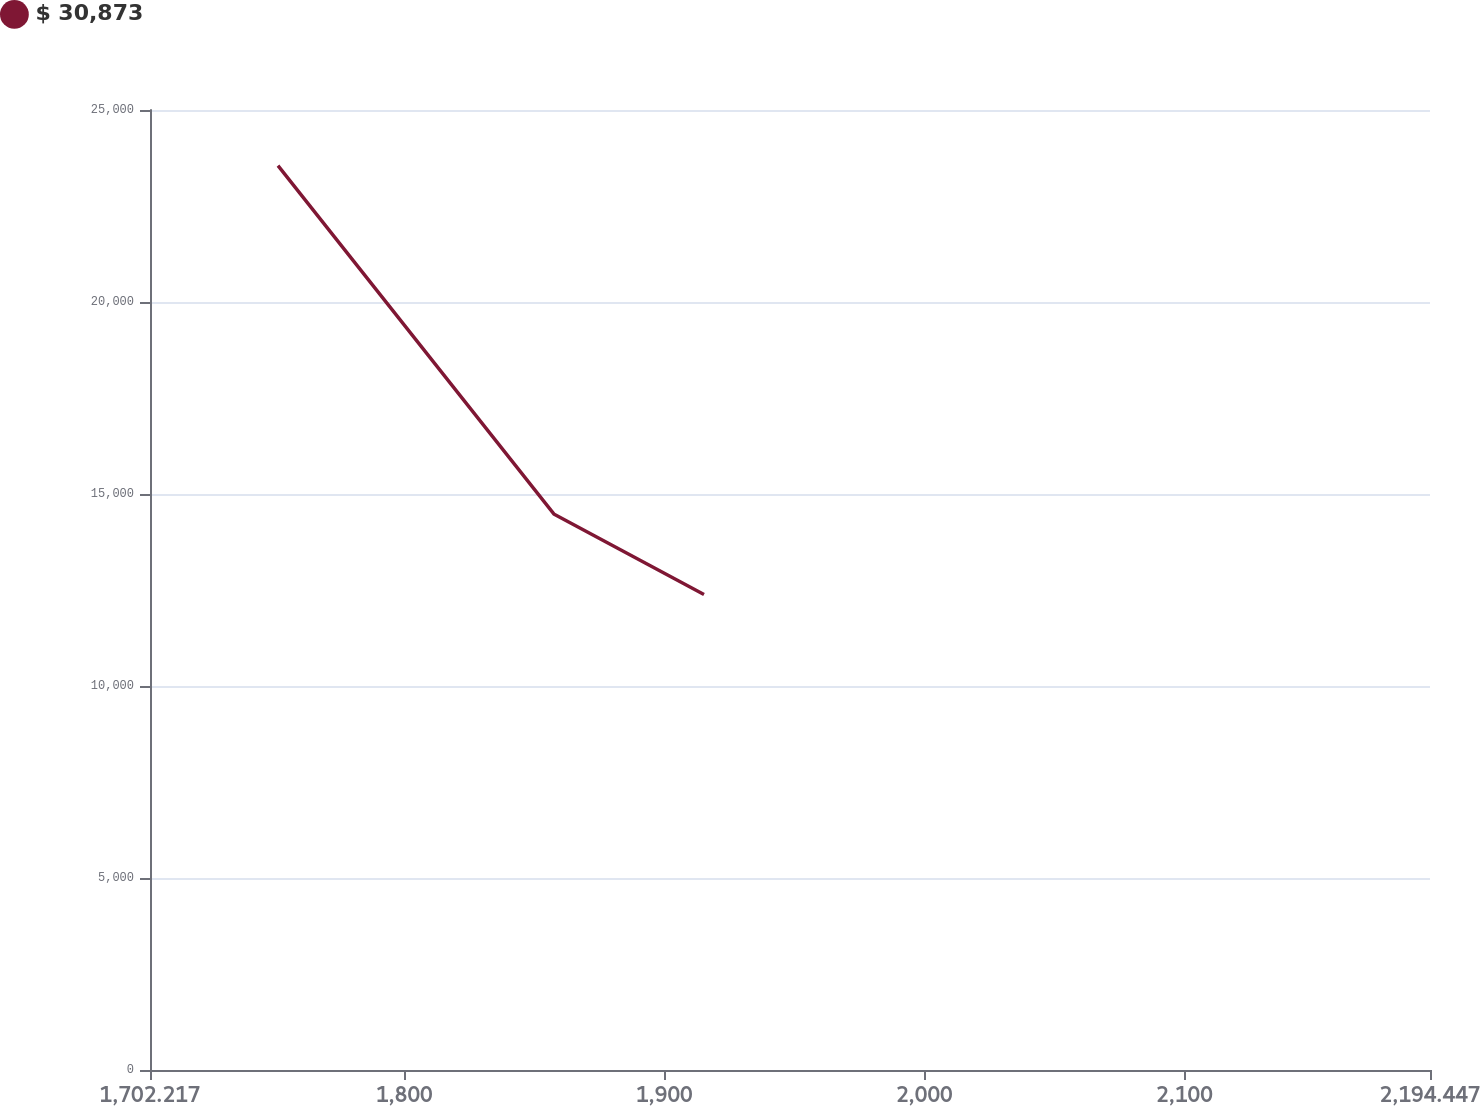Convert chart to OTSL. <chart><loc_0><loc_0><loc_500><loc_500><line_chart><ecel><fcel>$ 30,873<nl><fcel>1751.44<fcel>23552.8<nl><fcel>1857.66<fcel>14470.1<nl><fcel>1915.26<fcel>12384.9<nl><fcel>2243.67<fcel>6603.27<nl></chart> 